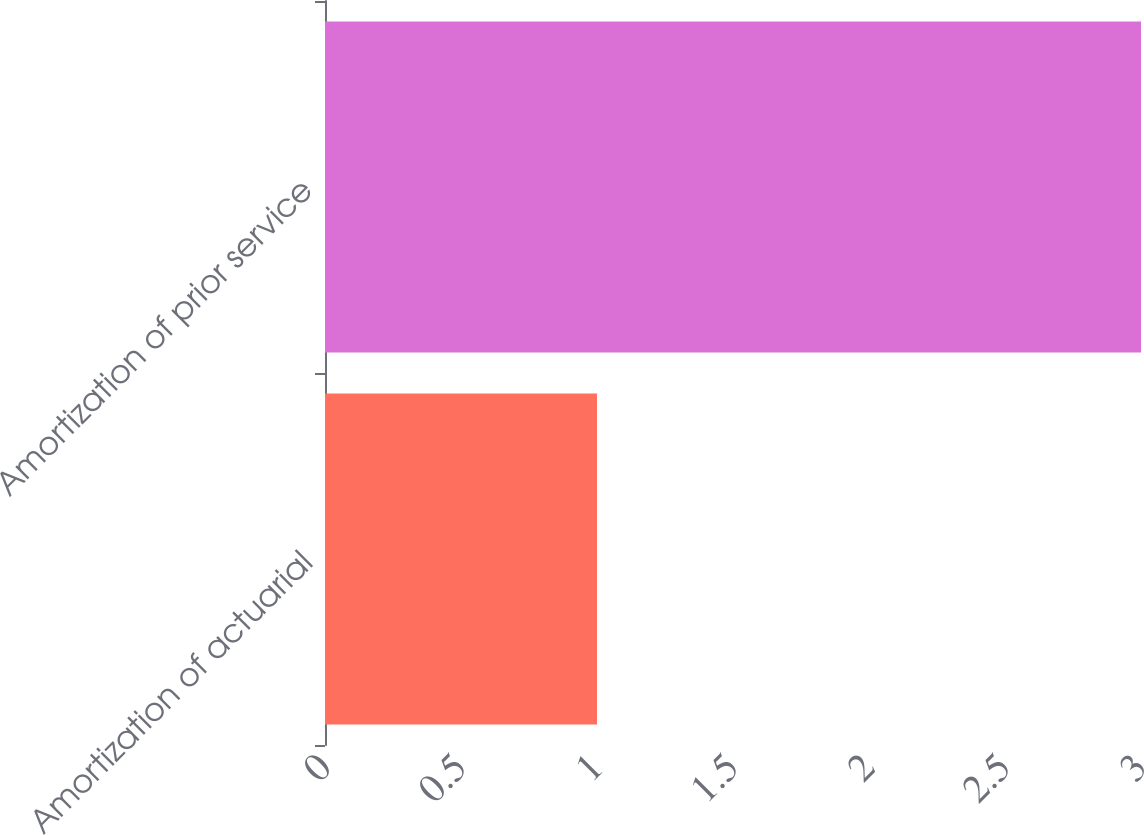<chart> <loc_0><loc_0><loc_500><loc_500><bar_chart><fcel>Amortization of actuarial<fcel>Amortization of prior service<nl><fcel>1<fcel>3<nl></chart> 